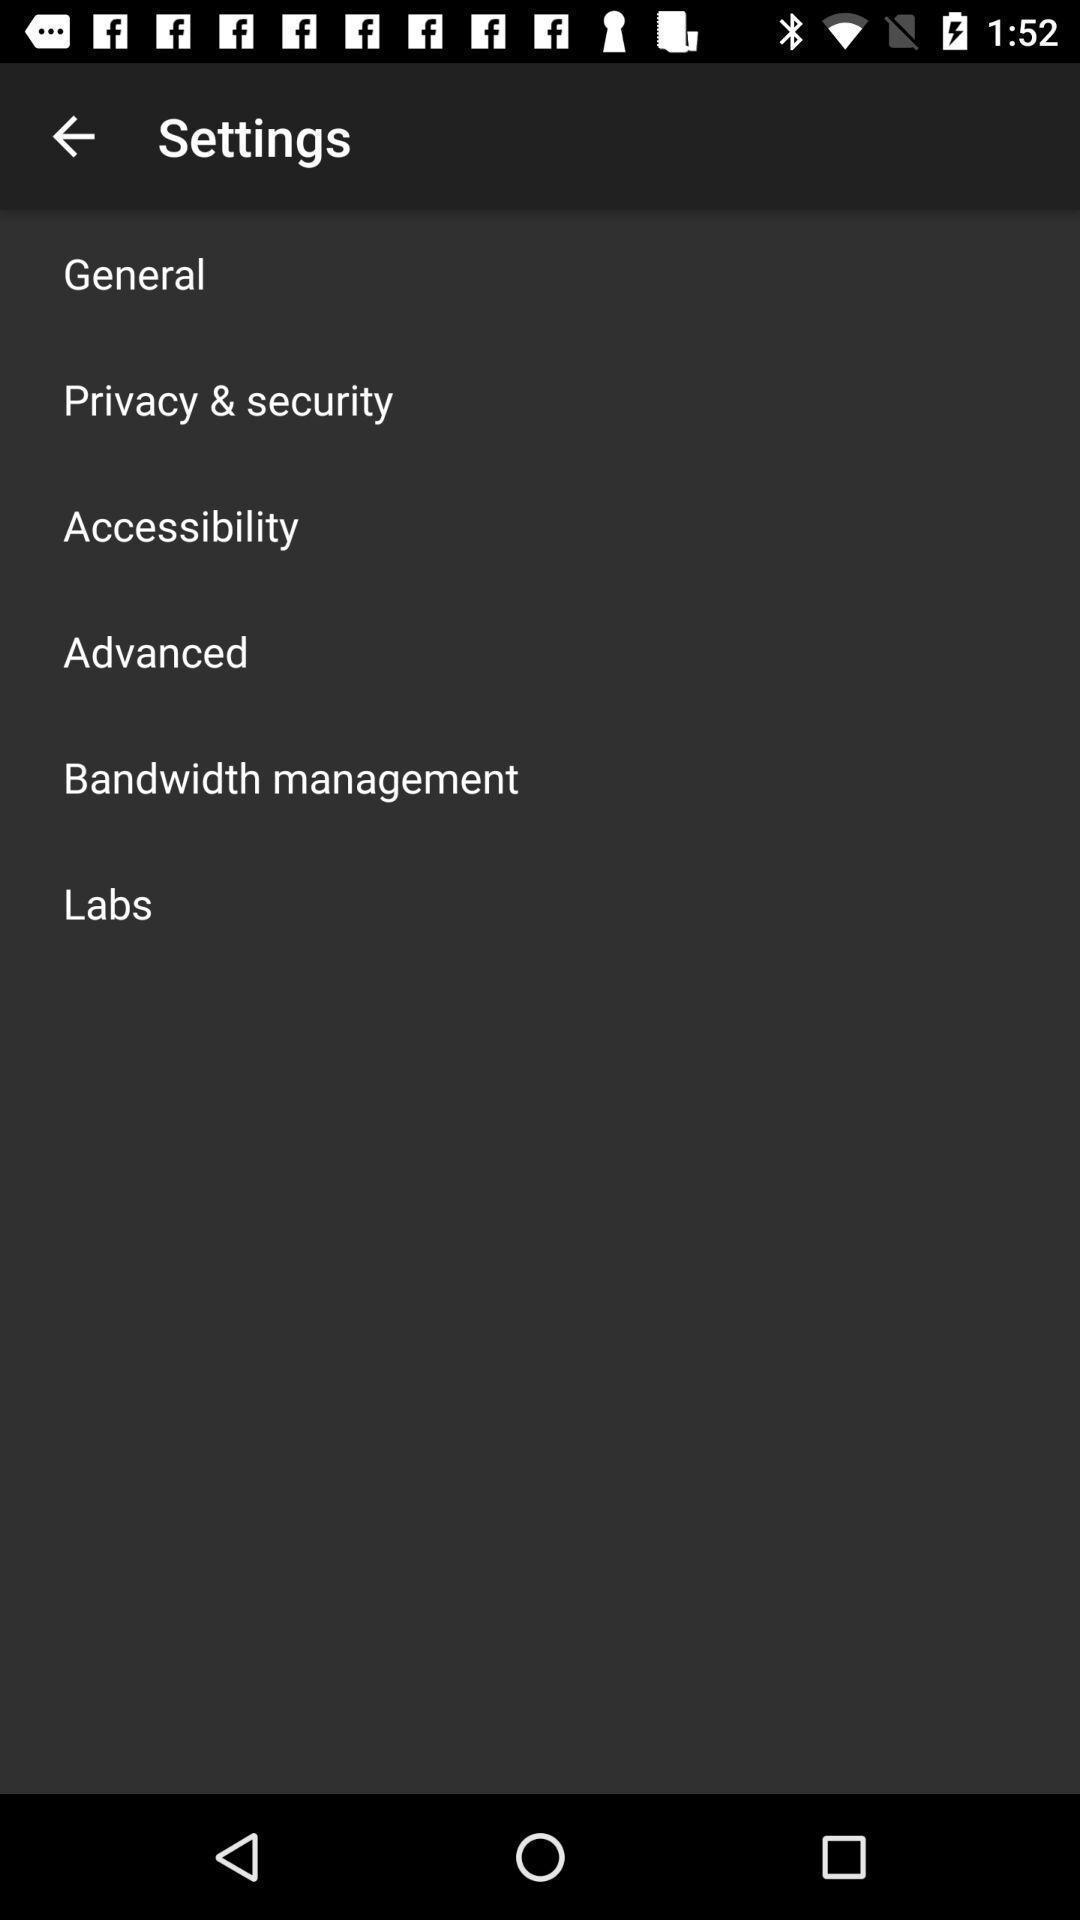Give me a summary of this screen capture. Settings page. 